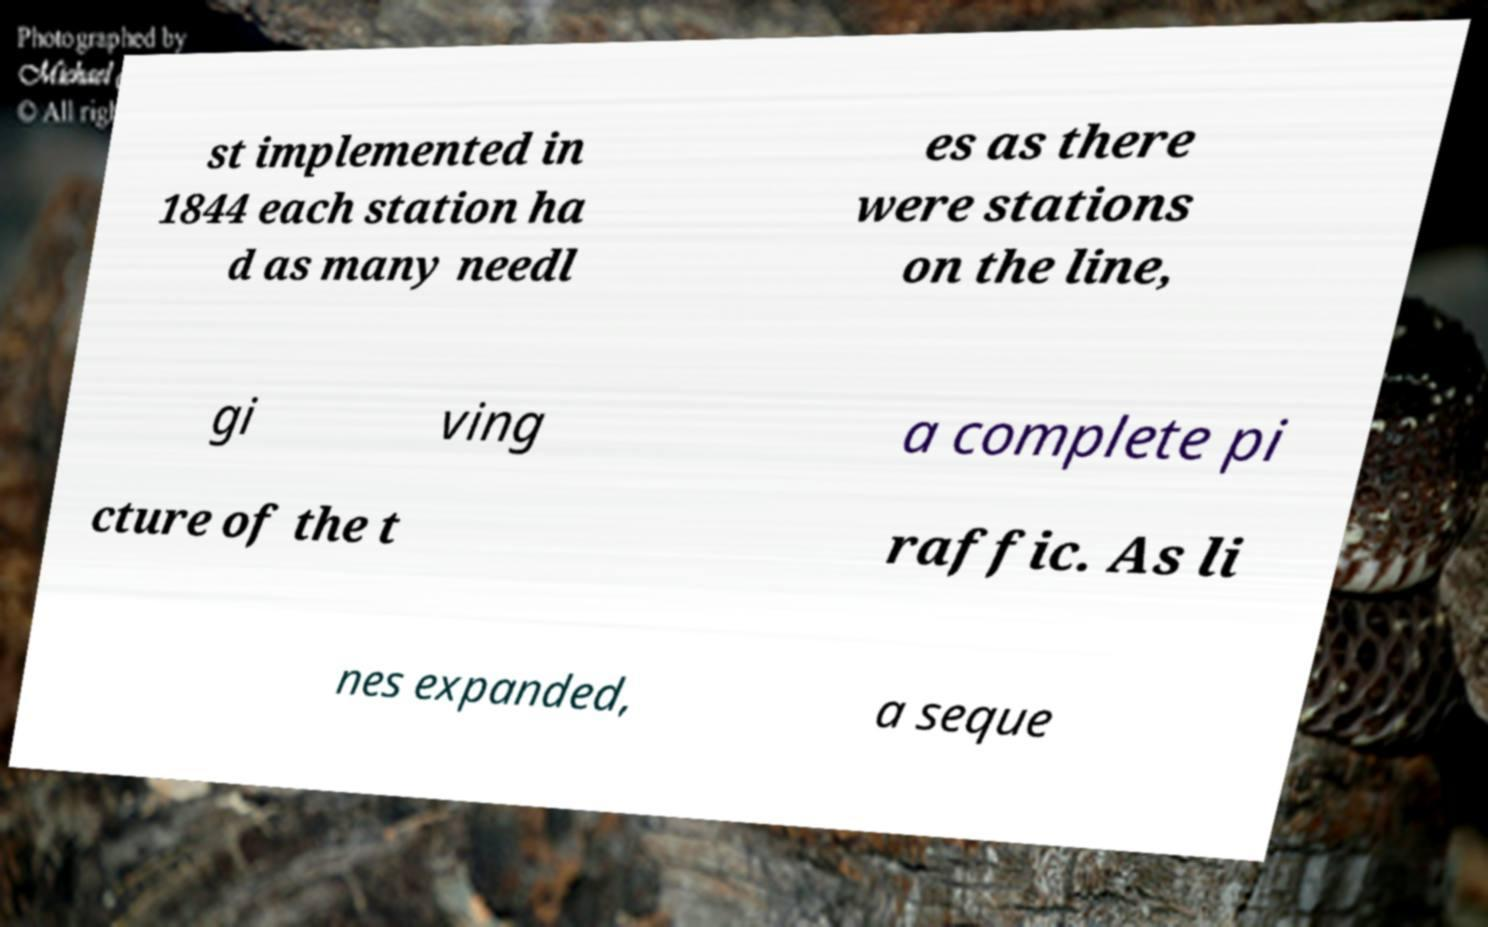I need the written content from this picture converted into text. Can you do that? st implemented in 1844 each station ha d as many needl es as there were stations on the line, gi ving a complete pi cture of the t raffic. As li nes expanded, a seque 